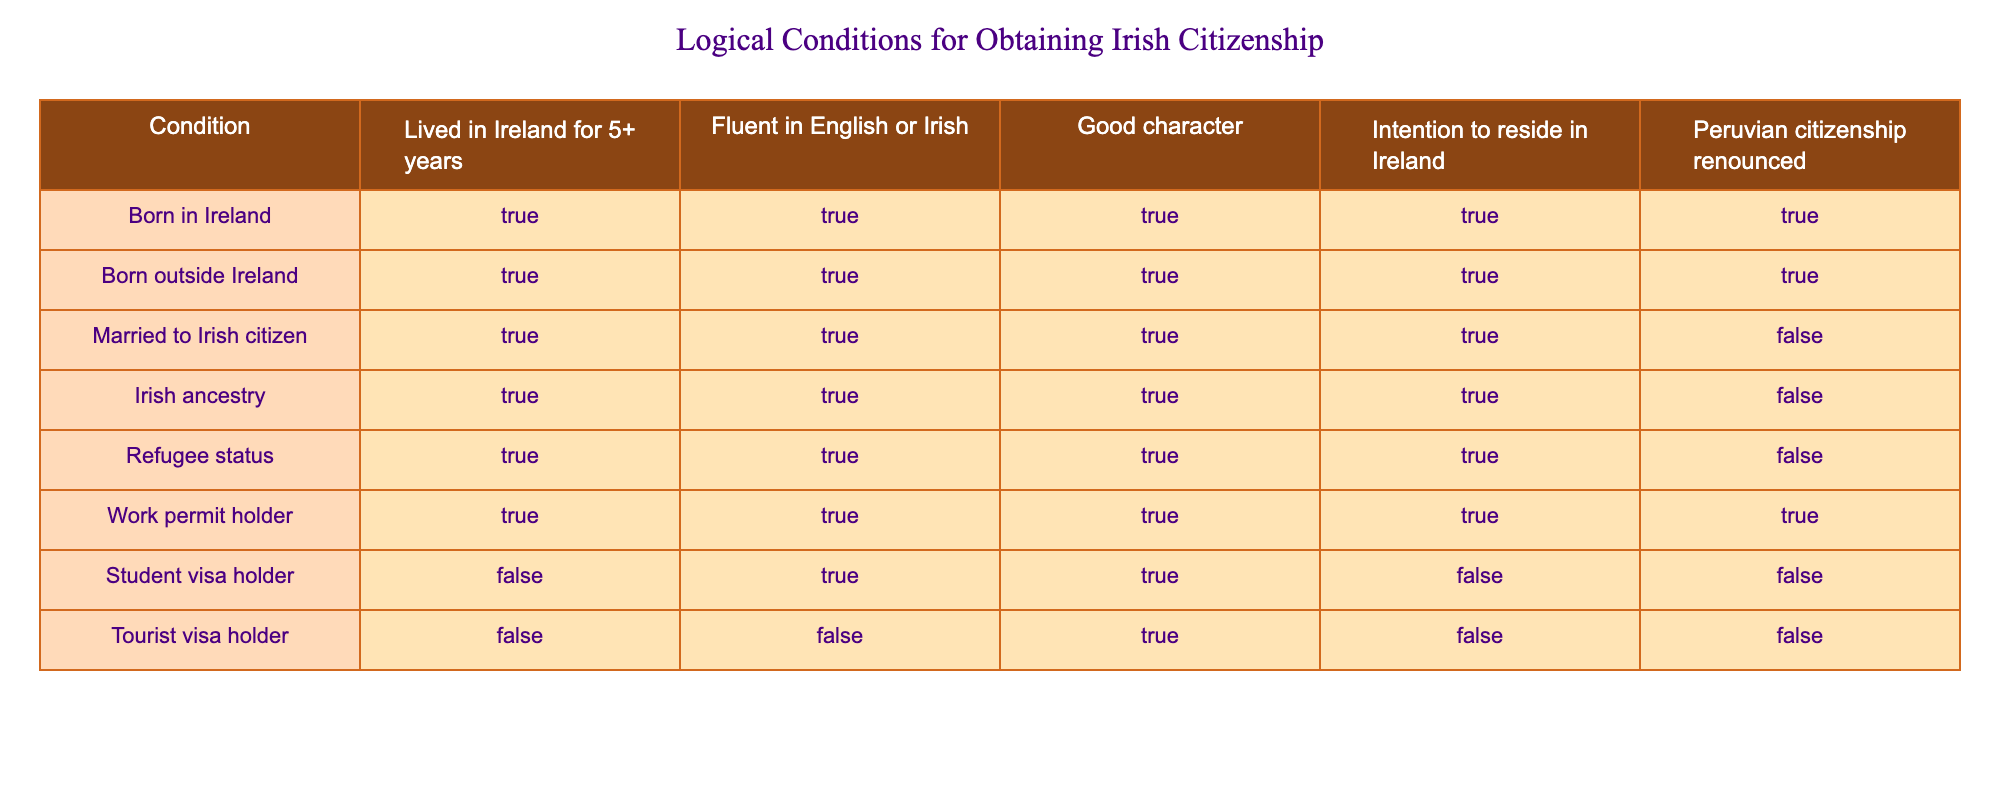What is the condition for someone born in Ireland to acquire Irish citizenship? According to the table, individuals born in Ireland meet all conditions: they have lived in Ireland for 5+ years, are fluent in English or Irish, have good character, intend to reside in Ireland, and have renounced their Peruvian citizenship.
Answer: All conditions met How many conditions must a refugee meet to obtain Irish citizenship? The table indicates that individuals with refugee status meet all five conditions: they must have lived in Ireland for 5+ years, be fluent in English or Irish, have good character, intend to reside in Ireland, and have renounced their Peruvian citizenship. Hence, they must meet all conditions.
Answer: All conditions must be met Can someone on a student visa acquire Irish citizenship? The table shows that a student visa holder does not live in Ireland for 5+ years and does not intend to reside in Ireland, but is fluent in English or Irish and has good character. Since both residency conditions are not met, they cannot acquire citizenship.
Answer: No What is the minimum number of conditions that a married person must meet to acquire Irish citizenship? For someone married to an Irish citizen, they meet four out of the five conditions. The only condition they do not meet is renouncing their Peruvian citizenship. This implies they need to meet at least four conditions.
Answer: Four conditions met Is being fluent in English sufficient to obtain citizenship if all other conditions are not met? The table indicates that fluency in English is just one of the several conditions. If the other conditions are not met, meeting this one condition alone is not sufficient to obtain citizenship.
Answer: No For individuals born outside Ireland, which two conditions are always true regardless of other factors? From the table, individuals born outside Ireland do meet fluent in English or Irish and have good character, regardless of their residency duration or Peruvian citizenship status. Therefore, these two conditions are always satisfied.
Answer: Fluent in English or Irish, good character If someone has good character but has lived in Ireland for less than a year, can they acquire Irish citizenship? The table shows that they would not meet the necessary condition of having lived in Ireland for 5+ years, which is a critical requirement for acquiring citizenship. Therefore, they cannot be granted citizenship even with good character.
Answer: No What is the outcome for a tourist visa holder regarding Irish citizenship? The table indicates that a tourist visa holder fails to meet multiple conditions: they have not lived in Ireland for 5+ years, are not fluent in English or Irish, and do not intend to reside in Ireland. Thus, a tourist visa holder cannot acquire citizenship.
Answer: Cannot acquire citizenship How does marital status influence the ability to acquire Irish citizenship? The table shows that being married to an Irish citizen allows for meeting most conditions (4 out of 5), but it does not compensate for the requirement to renounce Peruvian citizenship. Therefore, while marital status helps, it does not guarantee citizenship.
Answer: Helps but does not guarantee What is the total number of conditions met by a work permit holder? According to the table, a work permit holder meets all five conditions: they have lived in Ireland for 5+ years, are fluent in English or Irish, have good character, intend to reside in Ireland, and have renounced their Peruvian citizenship.
Answer: Five conditions met 